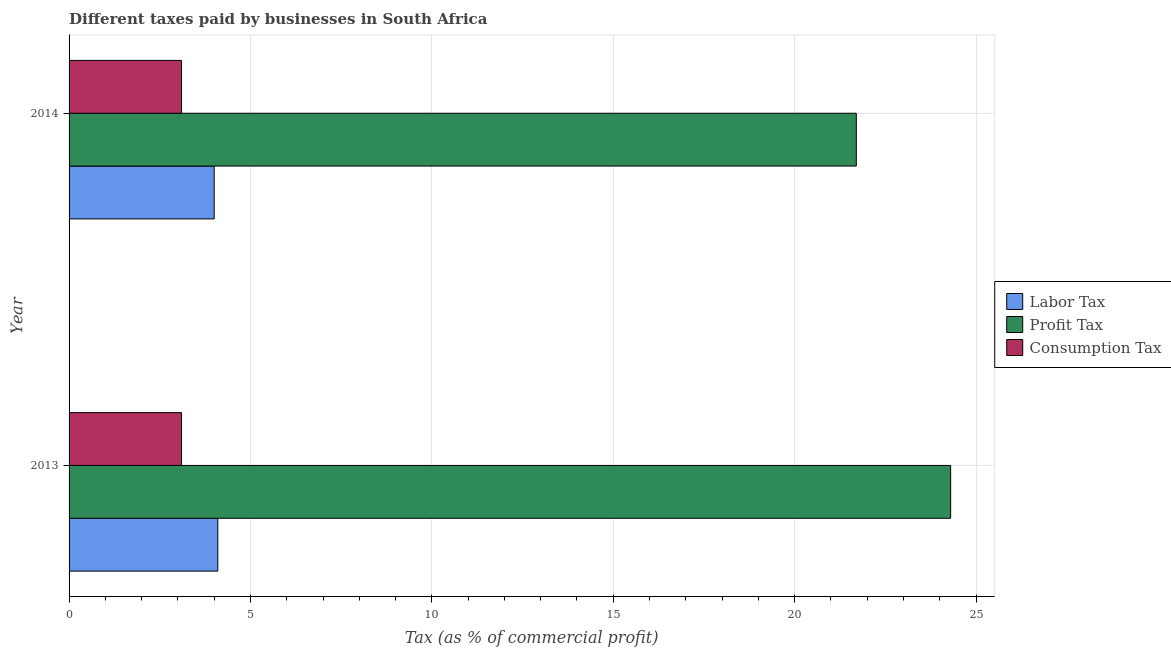How many different coloured bars are there?
Ensure brevity in your answer.  3. How many groups of bars are there?
Offer a very short reply. 2. Are the number of bars per tick equal to the number of legend labels?
Give a very brief answer. Yes. Are the number of bars on each tick of the Y-axis equal?
Keep it short and to the point. Yes. What is the label of the 2nd group of bars from the top?
Offer a very short reply. 2013. In how many cases, is the number of bars for a given year not equal to the number of legend labels?
Your answer should be compact. 0. What is the percentage of profit tax in 2014?
Your answer should be compact. 21.7. Across all years, what is the maximum percentage of profit tax?
Make the answer very short. 24.3. Across all years, what is the minimum percentage of profit tax?
Your answer should be very brief. 21.7. What is the total percentage of labor tax in the graph?
Ensure brevity in your answer.  8.1. What is the difference between the percentage of profit tax in 2013 and that in 2014?
Your answer should be compact. 2.6. What is the difference between the percentage of profit tax in 2013 and the percentage of consumption tax in 2014?
Provide a succinct answer. 21.2. What is the average percentage of labor tax per year?
Your response must be concise. 4.05. In the year 2013, what is the difference between the percentage of consumption tax and percentage of labor tax?
Your answer should be compact. -1. In how many years, is the percentage of consumption tax greater than 16 %?
Ensure brevity in your answer.  0. In how many years, is the percentage of labor tax greater than the average percentage of labor tax taken over all years?
Keep it short and to the point. 1. What does the 1st bar from the top in 2013 represents?
Your response must be concise. Consumption Tax. What does the 2nd bar from the bottom in 2014 represents?
Ensure brevity in your answer.  Profit Tax. Is it the case that in every year, the sum of the percentage of labor tax and percentage of profit tax is greater than the percentage of consumption tax?
Give a very brief answer. Yes. How many bars are there?
Your answer should be compact. 6. How many years are there in the graph?
Keep it short and to the point. 2. Does the graph contain grids?
Ensure brevity in your answer.  Yes. How many legend labels are there?
Your response must be concise. 3. How are the legend labels stacked?
Your answer should be very brief. Vertical. What is the title of the graph?
Offer a terse response. Different taxes paid by businesses in South Africa. What is the label or title of the X-axis?
Ensure brevity in your answer.  Tax (as % of commercial profit). What is the Tax (as % of commercial profit) of Labor Tax in 2013?
Your answer should be compact. 4.1. What is the Tax (as % of commercial profit) of Profit Tax in 2013?
Your response must be concise. 24.3. What is the Tax (as % of commercial profit) in Consumption Tax in 2013?
Offer a terse response. 3.1. What is the Tax (as % of commercial profit) of Profit Tax in 2014?
Provide a short and direct response. 21.7. Across all years, what is the maximum Tax (as % of commercial profit) of Profit Tax?
Your answer should be very brief. 24.3. Across all years, what is the maximum Tax (as % of commercial profit) in Consumption Tax?
Your answer should be very brief. 3.1. Across all years, what is the minimum Tax (as % of commercial profit) in Profit Tax?
Give a very brief answer. 21.7. Across all years, what is the minimum Tax (as % of commercial profit) in Consumption Tax?
Give a very brief answer. 3.1. What is the total Tax (as % of commercial profit) in Labor Tax in the graph?
Make the answer very short. 8.1. What is the total Tax (as % of commercial profit) of Profit Tax in the graph?
Keep it short and to the point. 46. What is the total Tax (as % of commercial profit) of Consumption Tax in the graph?
Ensure brevity in your answer.  6.2. What is the difference between the Tax (as % of commercial profit) in Labor Tax in 2013 and that in 2014?
Provide a succinct answer. 0.1. What is the difference between the Tax (as % of commercial profit) of Profit Tax in 2013 and that in 2014?
Your response must be concise. 2.6. What is the difference between the Tax (as % of commercial profit) in Consumption Tax in 2013 and that in 2014?
Make the answer very short. 0. What is the difference between the Tax (as % of commercial profit) of Labor Tax in 2013 and the Tax (as % of commercial profit) of Profit Tax in 2014?
Make the answer very short. -17.6. What is the difference between the Tax (as % of commercial profit) of Profit Tax in 2013 and the Tax (as % of commercial profit) of Consumption Tax in 2014?
Your answer should be very brief. 21.2. What is the average Tax (as % of commercial profit) in Labor Tax per year?
Provide a succinct answer. 4.05. What is the average Tax (as % of commercial profit) in Profit Tax per year?
Provide a succinct answer. 23. In the year 2013, what is the difference between the Tax (as % of commercial profit) of Labor Tax and Tax (as % of commercial profit) of Profit Tax?
Give a very brief answer. -20.2. In the year 2013, what is the difference between the Tax (as % of commercial profit) in Profit Tax and Tax (as % of commercial profit) in Consumption Tax?
Offer a terse response. 21.2. In the year 2014, what is the difference between the Tax (as % of commercial profit) of Labor Tax and Tax (as % of commercial profit) of Profit Tax?
Give a very brief answer. -17.7. In the year 2014, what is the difference between the Tax (as % of commercial profit) in Labor Tax and Tax (as % of commercial profit) in Consumption Tax?
Provide a short and direct response. 0.9. What is the ratio of the Tax (as % of commercial profit) of Profit Tax in 2013 to that in 2014?
Your response must be concise. 1.12. What is the difference between the highest and the lowest Tax (as % of commercial profit) of Labor Tax?
Offer a very short reply. 0.1. What is the difference between the highest and the lowest Tax (as % of commercial profit) in Profit Tax?
Provide a short and direct response. 2.6. 